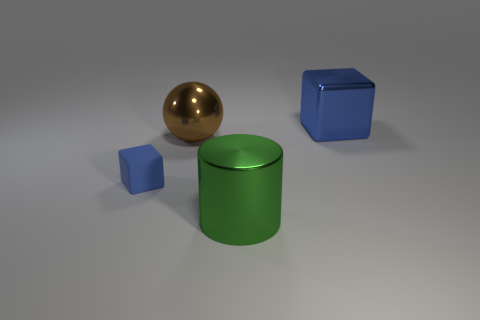How many small shiny blocks are there?
Offer a very short reply. 0. Are there the same number of brown spheres that are behind the metal cube and large green metal things that are behind the ball?
Offer a terse response. Yes. Are there any blocks behind the rubber cube?
Your response must be concise. Yes. What color is the block left of the blue metal thing?
Keep it short and to the point. Blue. What is the material of the tiny blue cube in front of the cube behind the large brown sphere?
Your answer should be compact. Rubber. Are there fewer blue metallic objects that are behind the large shiny cube than shiny balls on the left side of the brown sphere?
Offer a very short reply. No. What number of cyan objects are either large metallic things or blocks?
Keep it short and to the point. 0. Are there the same number of large green metallic things to the left of the big brown thing and tiny red metallic cylinders?
Give a very brief answer. Yes. What number of objects are big shiny balls or large objects on the left side of the large green cylinder?
Provide a succinct answer. 1. Do the metal block and the large metallic sphere have the same color?
Your response must be concise. No. 